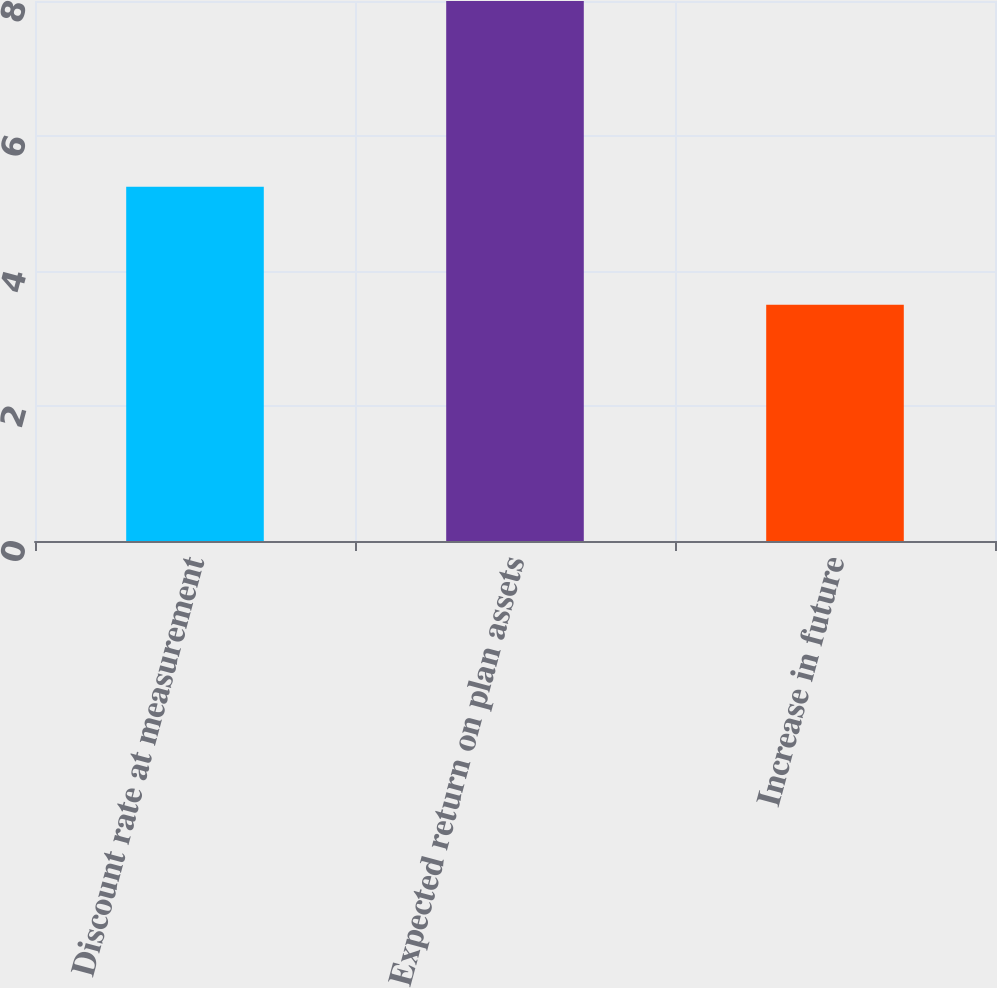Convert chart. <chart><loc_0><loc_0><loc_500><loc_500><bar_chart><fcel>Discount rate at measurement<fcel>Expected return on plan assets<fcel>Increase in future<nl><fcel>5.25<fcel>8<fcel>3.5<nl></chart> 